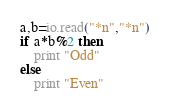<code> <loc_0><loc_0><loc_500><loc_500><_MoonScript_>a,b=io.read("*n","*n")
if a*b%2 then
	print "Odd"
else
	print "Even"</code> 